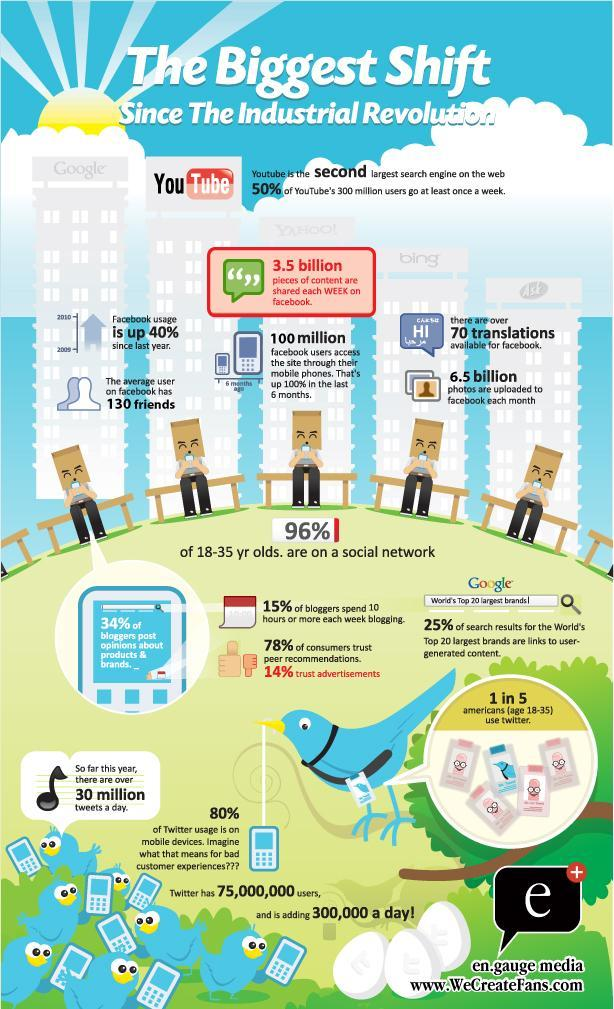How many photos are uploaded to facebook each month?
Answer the question with a short phrase. 6.5 billion What percentage of people in the age group of 18-35 years old are not on a social network? 4% What percentage of users do not use twitter in their mobile device? 20% What percentage of bloggers post opinions about products & brands? 34% 